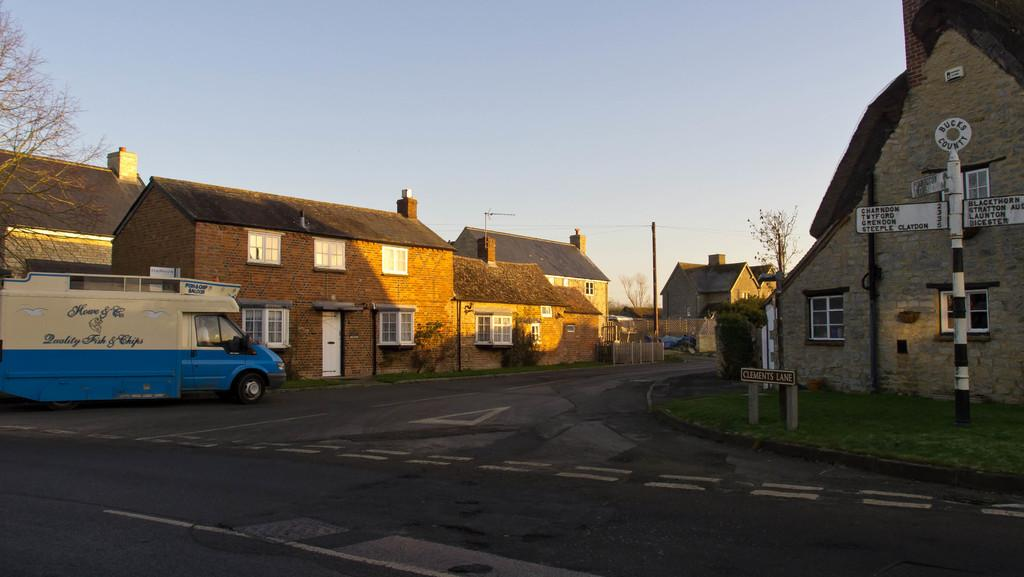What is the main feature of the image? There is a road in the image. What is on the road? There is a van on the road. What can be seen on either side of the road? There are houses and trees on either side of the road. What is visible in the background of the image? The sky is visible in the background of the image. Can you see any cobwebs hanging from the trees in the image? There is no mention of cobwebs in the image, so we cannot determine if any are present. What type of tongue is visible on the van in the image? There is no tongue present on the van or any other object in the image. 